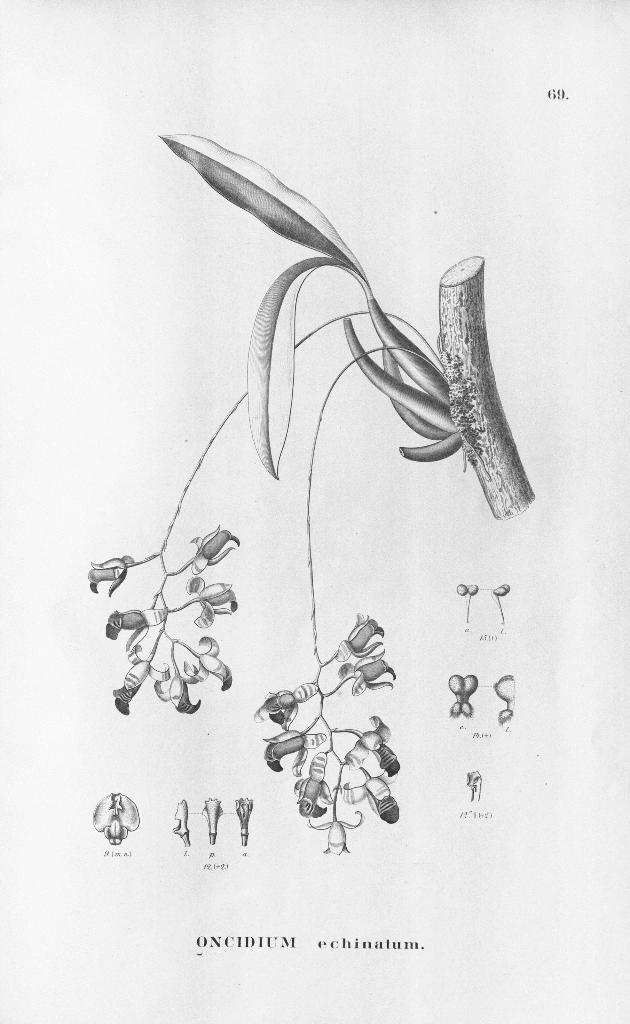What is depicted in the image? There is an art of a plant with flowers in the image. Are there any specific details about the plant in the image? Parts of the plant are labelled in the image. Is there any text in the image? Yes, there is edited text in the image. What type of crime is being committed in the image? There is no crime depicted in the image; it features an art of a plant with flowers and labelled parts. What kind of plate is used to serve the plant in the image? There is no plate present in the image; it only shows the art of a plant with flowers and labelled parts. 